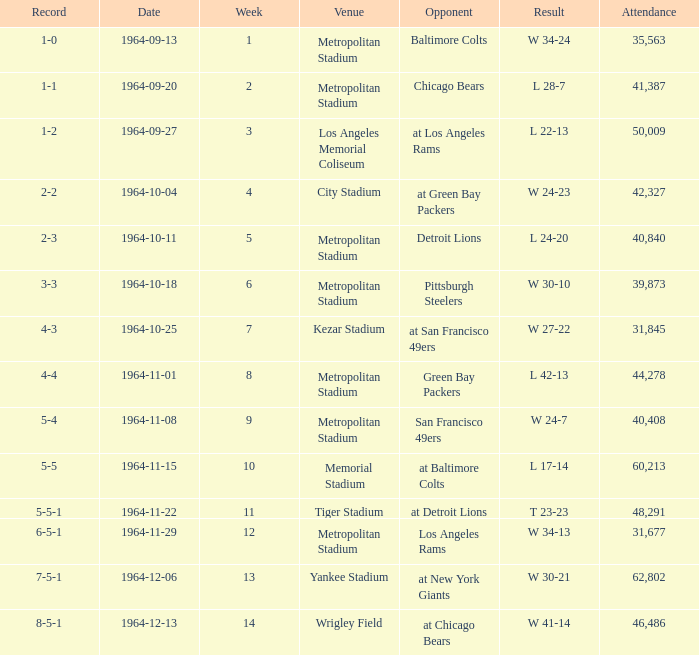What is the result when the record was 1-0 and it was earlier than week 4? W 34-24. Give me the full table as a dictionary. {'header': ['Record', 'Date', 'Week', 'Venue', 'Opponent', 'Result', 'Attendance'], 'rows': [['1-0', '1964-09-13', '1', 'Metropolitan Stadium', 'Baltimore Colts', 'W 34-24', '35,563'], ['1-1', '1964-09-20', '2', 'Metropolitan Stadium', 'Chicago Bears', 'L 28-7', '41,387'], ['1-2', '1964-09-27', '3', 'Los Angeles Memorial Coliseum', 'at Los Angeles Rams', 'L 22-13', '50,009'], ['2-2', '1964-10-04', '4', 'City Stadium', 'at Green Bay Packers', 'W 24-23', '42,327'], ['2-3', '1964-10-11', '5', 'Metropolitan Stadium', 'Detroit Lions', 'L 24-20', '40,840'], ['3-3', '1964-10-18', '6', 'Metropolitan Stadium', 'Pittsburgh Steelers', 'W 30-10', '39,873'], ['4-3', '1964-10-25', '7', 'Kezar Stadium', 'at San Francisco 49ers', 'W 27-22', '31,845'], ['4-4', '1964-11-01', '8', 'Metropolitan Stadium', 'Green Bay Packers', 'L 42-13', '44,278'], ['5-4', '1964-11-08', '9', 'Metropolitan Stadium', 'San Francisco 49ers', 'W 24-7', '40,408'], ['5-5', '1964-11-15', '10', 'Memorial Stadium', 'at Baltimore Colts', 'L 17-14', '60,213'], ['5-5-1', '1964-11-22', '11', 'Tiger Stadium', 'at Detroit Lions', 'T 23-23', '48,291'], ['6-5-1', '1964-11-29', '12', 'Metropolitan Stadium', 'Los Angeles Rams', 'W 34-13', '31,677'], ['7-5-1', '1964-12-06', '13', 'Yankee Stadium', 'at New York Giants', 'W 30-21', '62,802'], ['8-5-1', '1964-12-13', '14', 'Wrigley Field', 'at Chicago Bears', 'W 41-14', '46,486']]} 